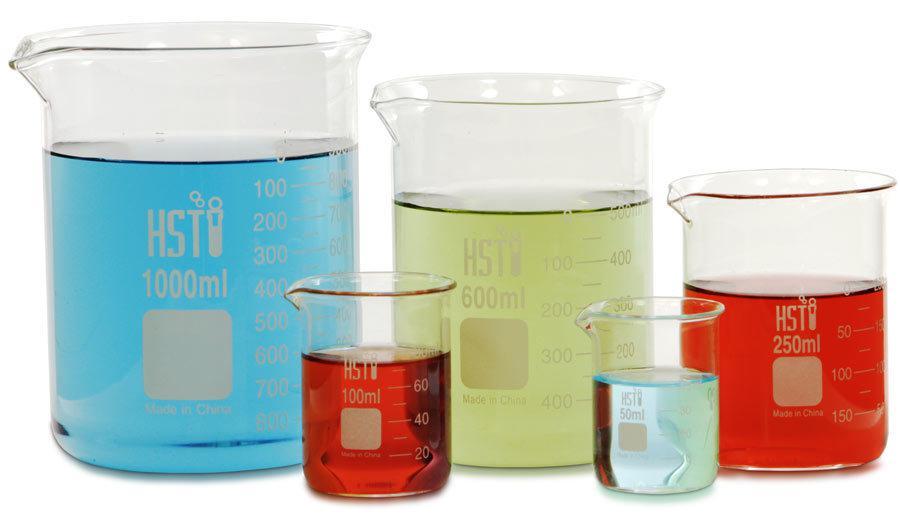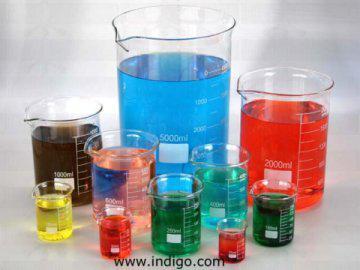The first image is the image on the left, the second image is the image on the right. Considering the images on both sides, is "There are more than five tubes filled with liquid in the image on the right." valid? Answer yes or no. Yes. The first image is the image on the left, the second image is the image on the right. Analyze the images presented: Is the assertion "In at least one image, the container on the far right contains a reddish liquid." valid? Answer yes or no. Yes. 